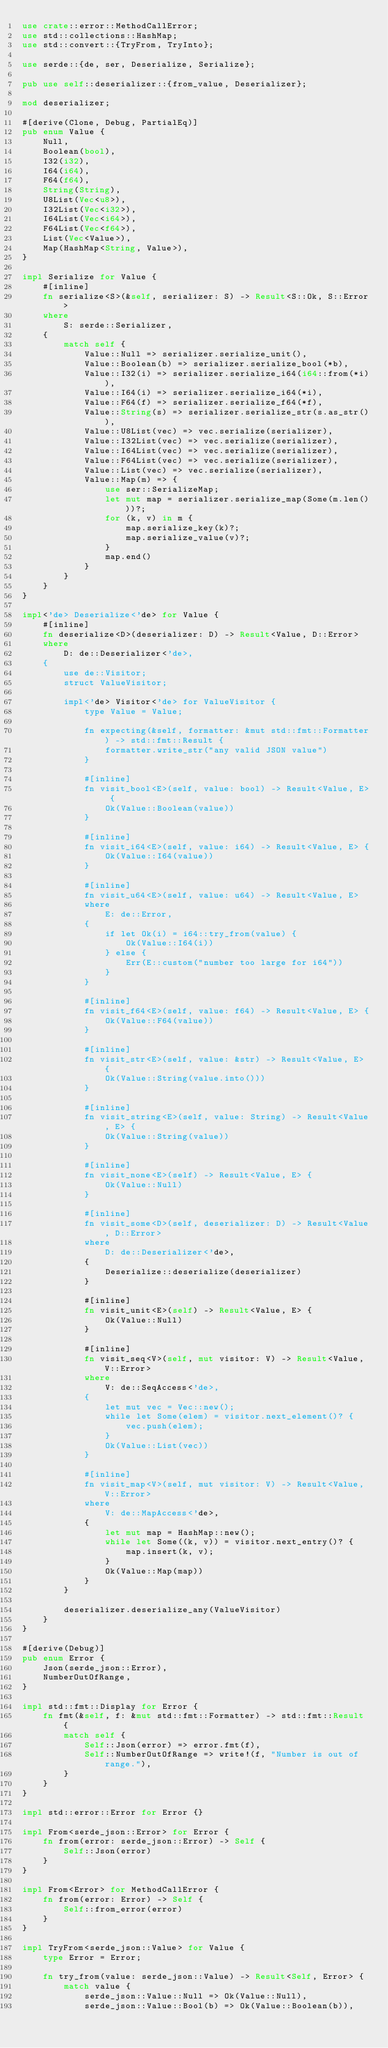Convert code to text. <code><loc_0><loc_0><loc_500><loc_500><_Rust_>use crate::error::MethodCallError;
use std::collections::HashMap;
use std::convert::{TryFrom, TryInto};

use serde::{de, ser, Deserialize, Serialize};

pub use self::deserializer::{from_value, Deserializer};

mod deserializer;

#[derive(Clone, Debug, PartialEq)]
pub enum Value {
    Null,
    Boolean(bool),
    I32(i32),
    I64(i64),
    F64(f64),
    String(String),
    U8List(Vec<u8>),
    I32List(Vec<i32>),
    I64List(Vec<i64>),
    F64List(Vec<f64>),
    List(Vec<Value>),
    Map(HashMap<String, Value>),
}

impl Serialize for Value {
    #[inline]
    fn serialize<S>(&self, serializer: S) -> Result<S::Ok, S::Error>
    where
        S: serde::Serializer,
    {
        match self {
            Value::Null => serializer.serialize_unit(),
            Value::Boolean(b) => serializer.serialize_bool(*b),
            Value::I32(i) => serializer.serialize_i64(i64::from(*i)),
            Value::I64(i) => serializer.serialize_i64(*i),
            Value::F64(f) => serializer.serialize_f64(*f),
            Value::String(s) => serializer.serialize_str(s.as_str()),
            Value::U8List(vec) => vec.serialize(serializer),
            Value::I32List(vec) => vec.serialize(serializer),
            Value::I64List(vec) => vec.serialize(serializer),
            Value::F64List(vec) => vec.serialize(serializer),
            Value::List(vec) => vec.serialize(serializer),
            Value::Map(m) => {
                use ser::SerializeMap;
                let mut map = serializer.serialize_map(Some(m.len()))?;
                for (k, v) in m {
                    map.serialize_key(k)?;
                    map.serialize_value(v)?;
                }
                map.end()
            }
        }
    }
}

impl<'de> Deserialize<'de> for Value {
    #[inline]
    fn deserialize<D>(deserializer: D) -> Result<Value, D::Error>
    where
        D: de::Deserializer<'de>,
    {
        use de::Visitor;
        struct ValueVisitor;

        impl<'de> Visitor<'de> for ValueVisitor {
            type Value = Value;

            fn expecting(&self, formatter: &mut std::fmt::Formatter) -> std::fmt::Result {
                formatter.write_str("any valid JSON value")
            }

            #[inline]
            fn visit_bool<E>(self, value: bool) -> Result<Value, E> {
                Ok(Value::Boolean(value))
            }

            #[inline]
            fn visit_i64<E>(self, value: i64) -> Result<Value, E> {
                Ok(Value::I64(value))
            }

            #[inline]
            fn visit_u64<E>(self, value: u64) -> Result<Value, E>
            where
                E: de::Error,
            {
                if let Ok(i) = i64::try_from(value) {
                    Ok(Value::I64(i))
                } else {
                    Err(E::custom("number too large for i64"))
                }
            }

            #[inline]
            fn visit_f64<E>(self, value: f64) -> Result<Value, E> {
                Ok(Value::F64(value))
            }

            #[inline]
            fn visit_str<E>(self, value: &str) -> Result<Value, E> {
                Ok(Value::String(value.into()))
            }

            #[inline]
            fn visit_string<E>(self, value: String) -> Result<Value, E> {
                Ok(Value::String(value))
            }

            #[inline]
            fn visit_none<E>(self) -> Result<Value, E> {
                Ok(Value::Null)
            }

            #[inline]
            fn visit_some<D>(self, deserializer: D) -> Result<Value, D::Error>
            where
                D: de::Deserializer<'de>,
            {
                Deserialize::deserialize(deserializer)
            }

            #[inline]
            fn visit_unit<E>(self) -> Result<Value, E> {
                Ok(Value::Null)
            }

            #[inline]
            fn visit_seq<V>(self, mut visitor: V) -> Result<Value, V::Error>
            where
                V: de::SeqAccess<'de>,
            {
                let mut vec = Vec::new();
                while let Some(elem) = visitor.next_element()? {
                    vec.push(elem);
                }
                Ok(Value::List(vec))
            }

            #[inline]
            fn visit_map<V>(self, mut visitor: V) -> Result<Value, V::Error>
            where
                V: de::MapAccess<'de>,
            {
                let mut map = HashMap::new();
                while let Some((k, v)) = visitor.next_entry()? {
                    map.insert(k, v);
                }
                Ok(Value::Map(map))
            }
        }

        deserializer.deserialize_any(ValueVisitor)
    }
}

#[derive(Debug)]
pub enum Error {
    Json(serde_json::Error),
    NumberOutOfRange,
}

impl std::fmt::Display for Error {
    fn fmt(&self, f: &mut std::fmt::Formatter) -> std::fmt::Result {
        match self {
            Self::Json(error) => error.fmt(f),
            Self::NumberOutOfRange => write!(f, "Number is out of range."),
        }
    }
}

impl std::error::Error for Error {}

impl From<serde_json::Error> for Error {
    fn from(error: serde_json::Error) -> Self {
        Self::Json(error)
    }
}

impl From<Error> for MethodCallError {
    fn from(error: Error) -> Self {
        Self::from_error(error)
    }
}

impl TryFrom<serde_json::Value> for Value {
    type Error = Error;

    fn try_from(value: serde_json::Value) -> Result<Self, Error> {
        match value {
            serde_json::Value::Null => Ok(Value::Null),
            serde_json::Value::Bool(b) => Ok(Value::Boolean(b)),</code> 